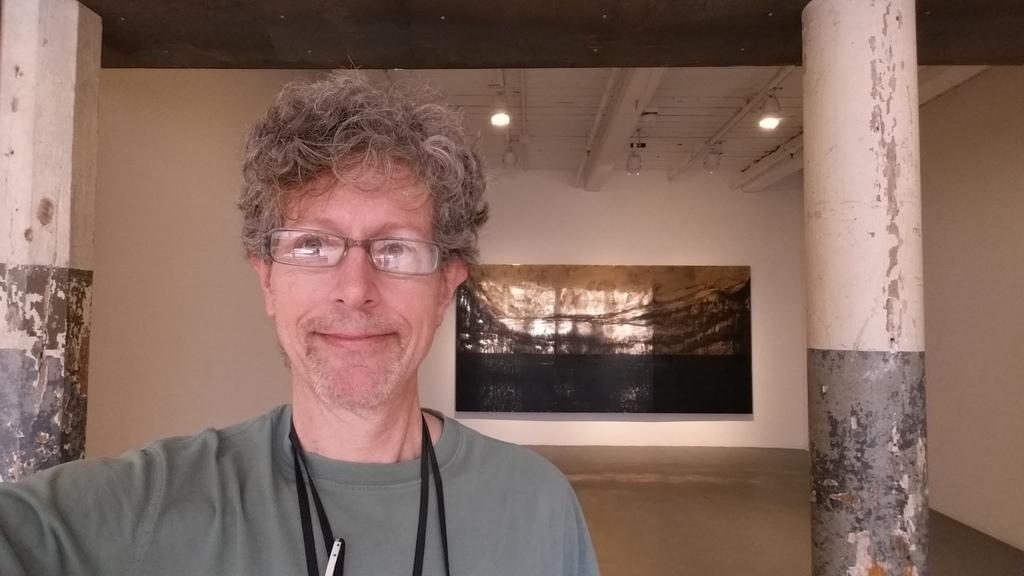What can be seen in the image? There is a person in the image. Can you describe the person's appearance? The person is wearing glasses and smiling. What can be seen in the background of the image? There is a painting, walls, pillars, the floor, the ceiling, and lights visible in the background. What type of grape is the person holding in the image? There is no grape present in the image; the person is not holding any object. What type of juice is being served in the cup in the image? There is no cup or juice present in the image. 